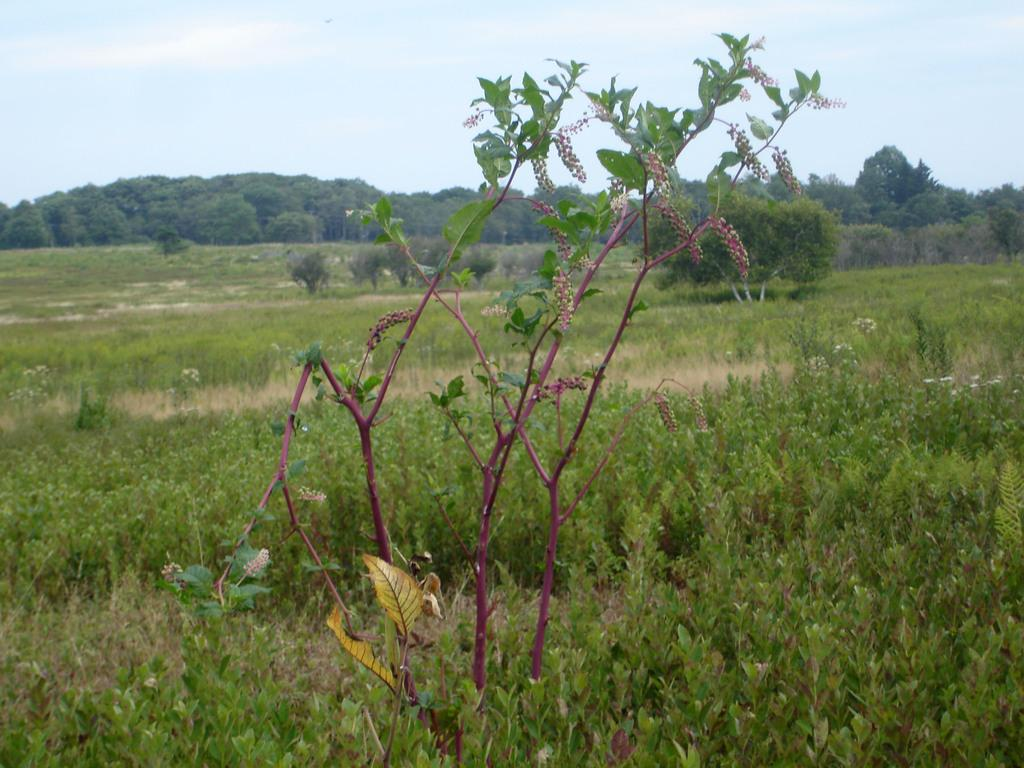What type of vegetation covers the land in the image? The land in the image is covered with bushes, plants, and trees. Can you describe the density of the vegetation in the image? The land appears to be densely covered with vegetation, including bushes, plants, and trees. What type of ink is being used to color the cattle in the image? There are no cattle present in the image, and therefore no ink is being used to color them. 